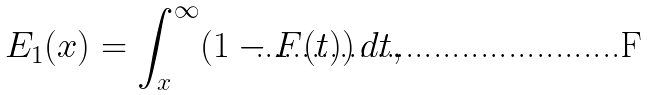<formula> <loc_0><loc_0><loc_500><loc_500>E _ { 1 } ( x ) = \int _ { x } ^ { \infty } ( 1 - F ( t ) ) \, d t ,</formula> 